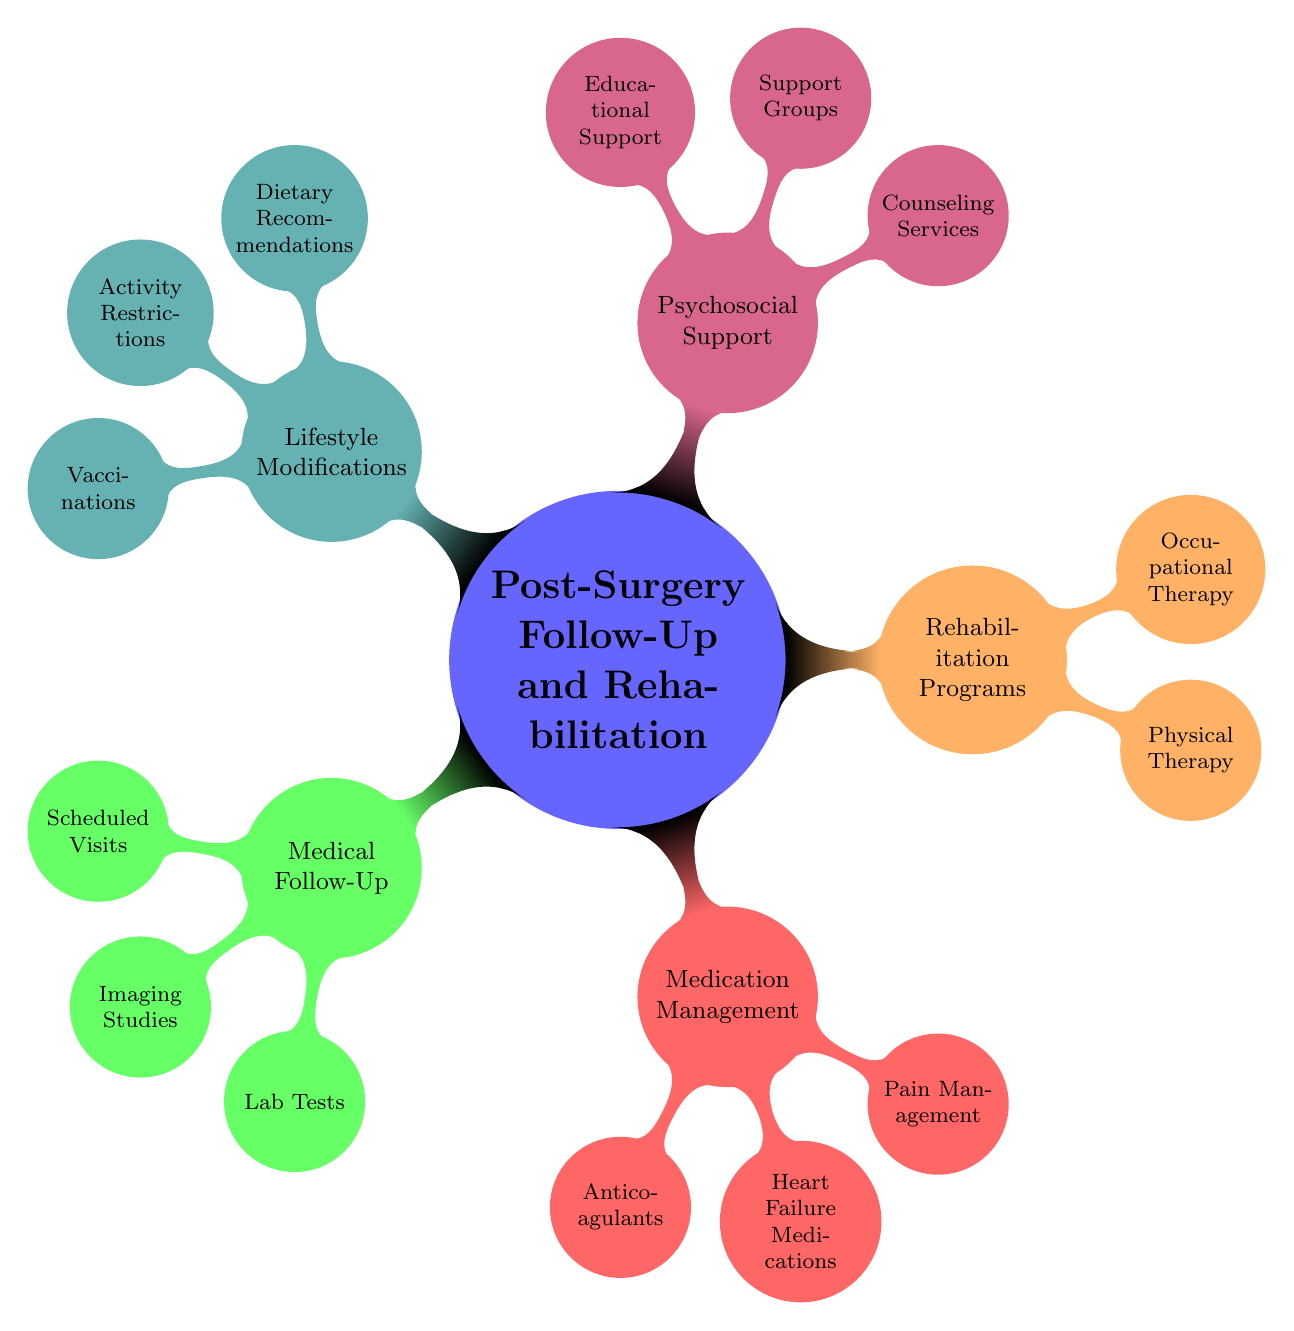What are the three main categories in the diagram? The main categories in the diagram are found at the first level beneath the central node. They include Medical Follow-Up, Medication Management, Rehabilitation Programs, Psychosocial Support, and Lifestyle Modifications.
Answer: Medical Follow-Up, Medication Management, Rehabilitation Programs, Psychosocial Support, Lifestyle Modifications How many scheduled visits are there listed in Medical Follow-Up? The node for Scheduled Visits under Medical Follow-Up contains a list of specific visits. Counting these, we find five scheduled visits.
Answer: 5 What are two types of exercises included in Physical Therapy? Physical Therapy is a sub-category under Rehabilitation Programs. It has two specific types of exercises listed: Cardiovascular Exercises and Strength Training. The question asks for any two, which can be chosen from the specific examples mentioned.
Answer: Treadmill, Resistance Bands What is one component of the Psychosocial Support category? The Psychosocial Support category includes multiple sub-components such as Counseling Services, Support Groups, and Educational Support. Any one of these can be identified as a component.
Answer: Counseling Services Which medication is listed under Pain Management? Pain Management is a subcategory within Medication Management, listing specific medications. Acetaminophen and Ibuprofen are mentioned under this node, one of which can be the answer.
Answer: Acetaminophen What is the relationship between Rehabilitation Programs and Psychosocial Support? Both Rehabilitation Programs and Psychosocial Support are main categories under the central theme of Post-Surgery Follow-Up and Rehabilitation. They represent different aspects of care, highlighting that both are essential for patient recovery.
Answer: Both support recovery What should be restricted according to the Activity Restrictions? The Activity Restrictions node specifies guidelines related to the physical activities a child can partake in after surgery, including Limited Physical Exertion and No Competitive Sports. The answer requires extracting one of these two restrictions.
Answer: Limited Physical Exertion Which vaccination is mentioned in the Lifestyle Modifications category? Under the Lifestyle Modifications node, there is a list that includes various Vaccinations, specifically the Annual Flu Shot and the Pneumococcal Vaccine. As the question asks for any vaccination mentioned, we could use either.
Answer: Annual Flu Shot 